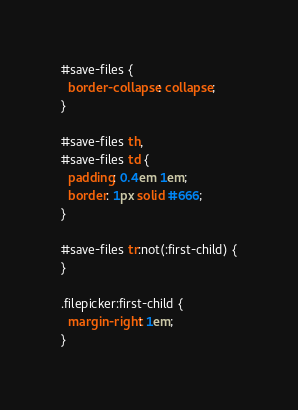Convert code to text. <code><loc_0><loc_0><loc_500><loc_500><_CSS_>#save-files {
  border-collapse: collapse;
}

#save-files th,
#save-files td {
  padding: 0.4em 1em;
  border: 1px solid #666;
}

#save-files tr:not(:first-child) {
}

.filepicker:first-child {
  margin-right: 1em;
}
</code> 